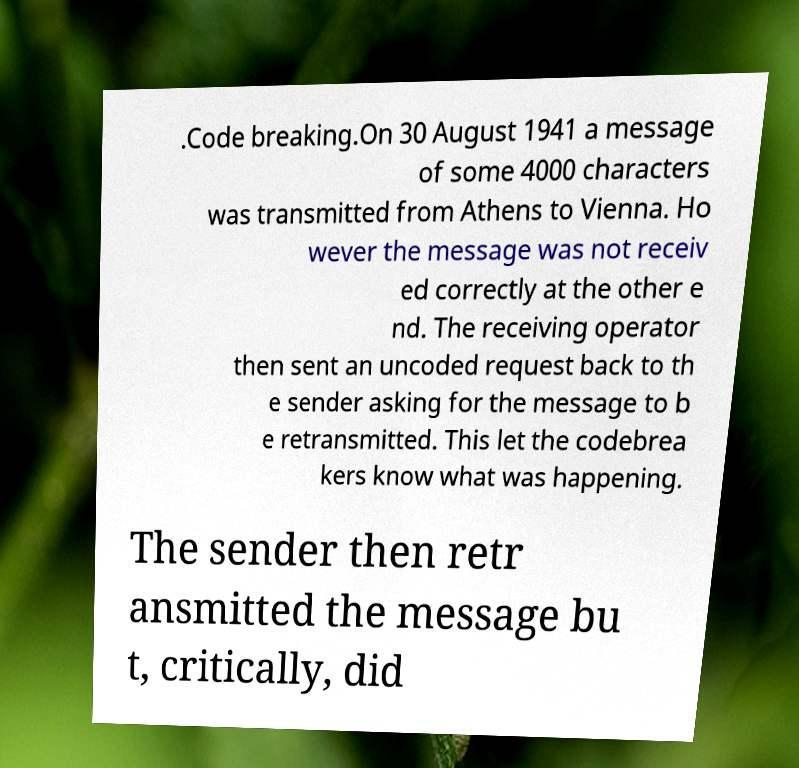Could you extract and type out the text from this image? .Code breaking.On 30 August 1941 a message of some 4000 characters was transmitted from Athens to Vienna. Ho wever the message was not receiv ed correctly at the other e nd. The receiving operator then sent an uncoded request back to th e sender asking for the message to b e retransmitted. This let the codebrea kers know what was happening. The sender then retr ansmitted the message bu t, critically, did 